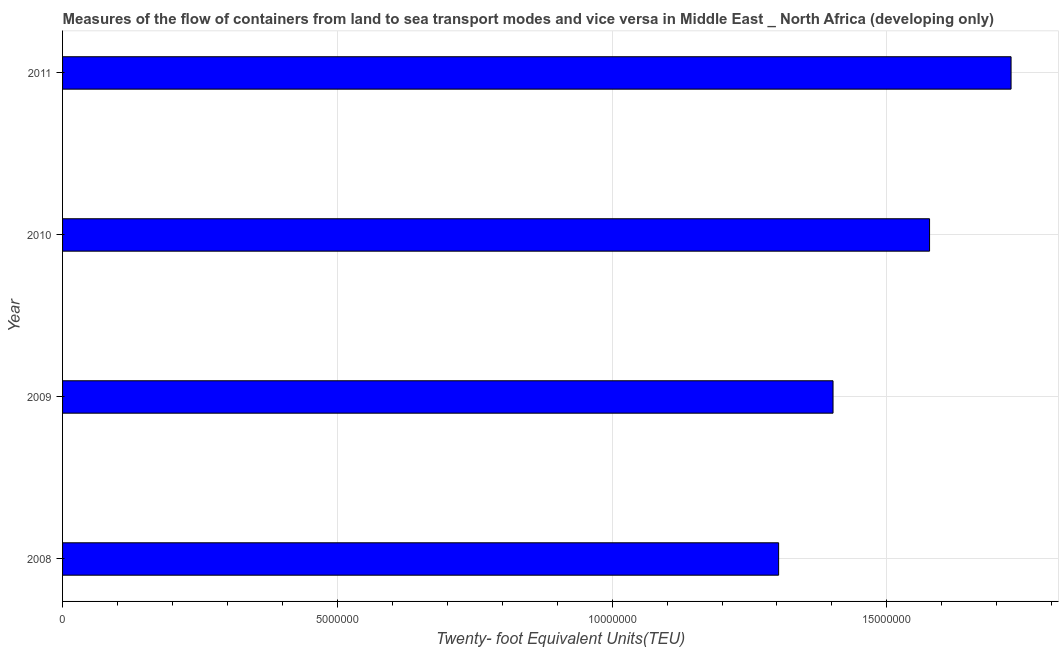Does the graph contain grids?
Make the answer very short. Yes. What is the title of the graph?
Give a very brief answer. Measures of the flow of containers from land to sea transport modes and vice versa in Middle East _ North Africa (developing only). What is the label or title of the X-axis?
Your answer should be very brief. Twenty- foot Equivalent Units(TEU). What is the container port traffic in 2008?
Your answer should be very brief. 1.30e+07. Across all years, what is the maximum container port traffic?
Your answer should be compact. 1.73e+07. Across all years, what is the minimum container port traffic?
Your response must be concise. 1.30e+07. In which year was the container port traffic minimum?
Keep it short and to the point. 2008. What is the sum of the container port traffic?
Make the answer very short. 6.01e+07. What is the difference between the container port traffic in 2008 and 2009?
Your response must be concise. -9.90e+05. What is the average container port traffic per year?
Your response must be concise. 1.50e+07. What is the median container port traffic?
Offer a very short reply. 1.49e+07. In how many years, is the container port traffic greater than 14000000 TEU?
Offer a terse response. 3. What is the ratio of the container port traffic in 2009 to that in 2010?
Offer a terse response. 0.89. What is the difference between the highest and the second highest container port traffic?
Your response must be concise. 1.48e+06. What is the difference between the highest and the lowest container port traffic?
Offer a terse response. 4.23e+06. In how many years, is the container port traffic greater than the average container port traffic taken over all years?
Offer a terse response. 2. How many bars are there?
Your response must be concise. 4. Are all the bars in the graph horizontal?
Your answer should be compact. Yes. What is the Twenty- foot Equivalent Units(TEU) in 2008?
Provide a succinct answer. 1.30e+07. What is the Twenty- foot Equivalent Units(TEU) in 2009?
Your answer should be compact. 1.40e+07. What is the Twenty- foot Equivalent Units(TEU) of 2010?
Make the answer very short. 1.58e+07. What is the Twenty- foot Equivalent Units(TEU) of 2011?
Keep it short and to the point. 1.73e+07. What is the difference between the Twenty- foot Equivalent Units(TEU) in 2008 and 2009?
Ensure brevity in your answer.  -9.90e+05. What is the difference between the Twenty- foot Equivalent Units(TEU) in 2008 and 2010?
Provide a short and direct response. -2.75e+06. What is the difference between the Twenty- foot Equivalent Units(TEU) in 2008 and 2011?
Offer a terse response. -4.23e+06. What is the difference between the Twenty- foot Equivalent Units(TEU) in 2009 and 2010?
Provide a succinct answer. -1.76e+06. What is the difference between the Twenty- foot Equivalent Units(TEU) in 2009 and 2011?
Make the answer very short. -3.24e+06. What is the difference between the Twenty- foot Equivalent Units(TEU) in 2010 and 2011?
Offer a terse response. -1.48e+06. What is the ratio of the Twenty- foot Equivalent Units(TEU) in 2008 to that in 2009?
Offer a terse response. 0.93. What is the ratio of the Twenty- foot Equivalent Units(TEU) in 2008 to that in 2010?
Offer a very short reply. 0.83. What is the ratio of the Twenty- foot Equivalent Units(TEU) in 2008 to that in 2011?
Offer a very short reply. 0.76. What is the ratio of the Twenty- foot Equivalent Units(TEU) in 2009 to that in 2010?
Your answer should be compact. 0.89. What is the ratio of the Twenty- foot Equivalent Units(TEU) in 2009 to that in 2011?
Offer a terse response. 0.81. What is the ratio of the Twenty- foot Equivalent Units(TEU) in 2010 to that in 2011?
Offer a very short reply. 0.91. 